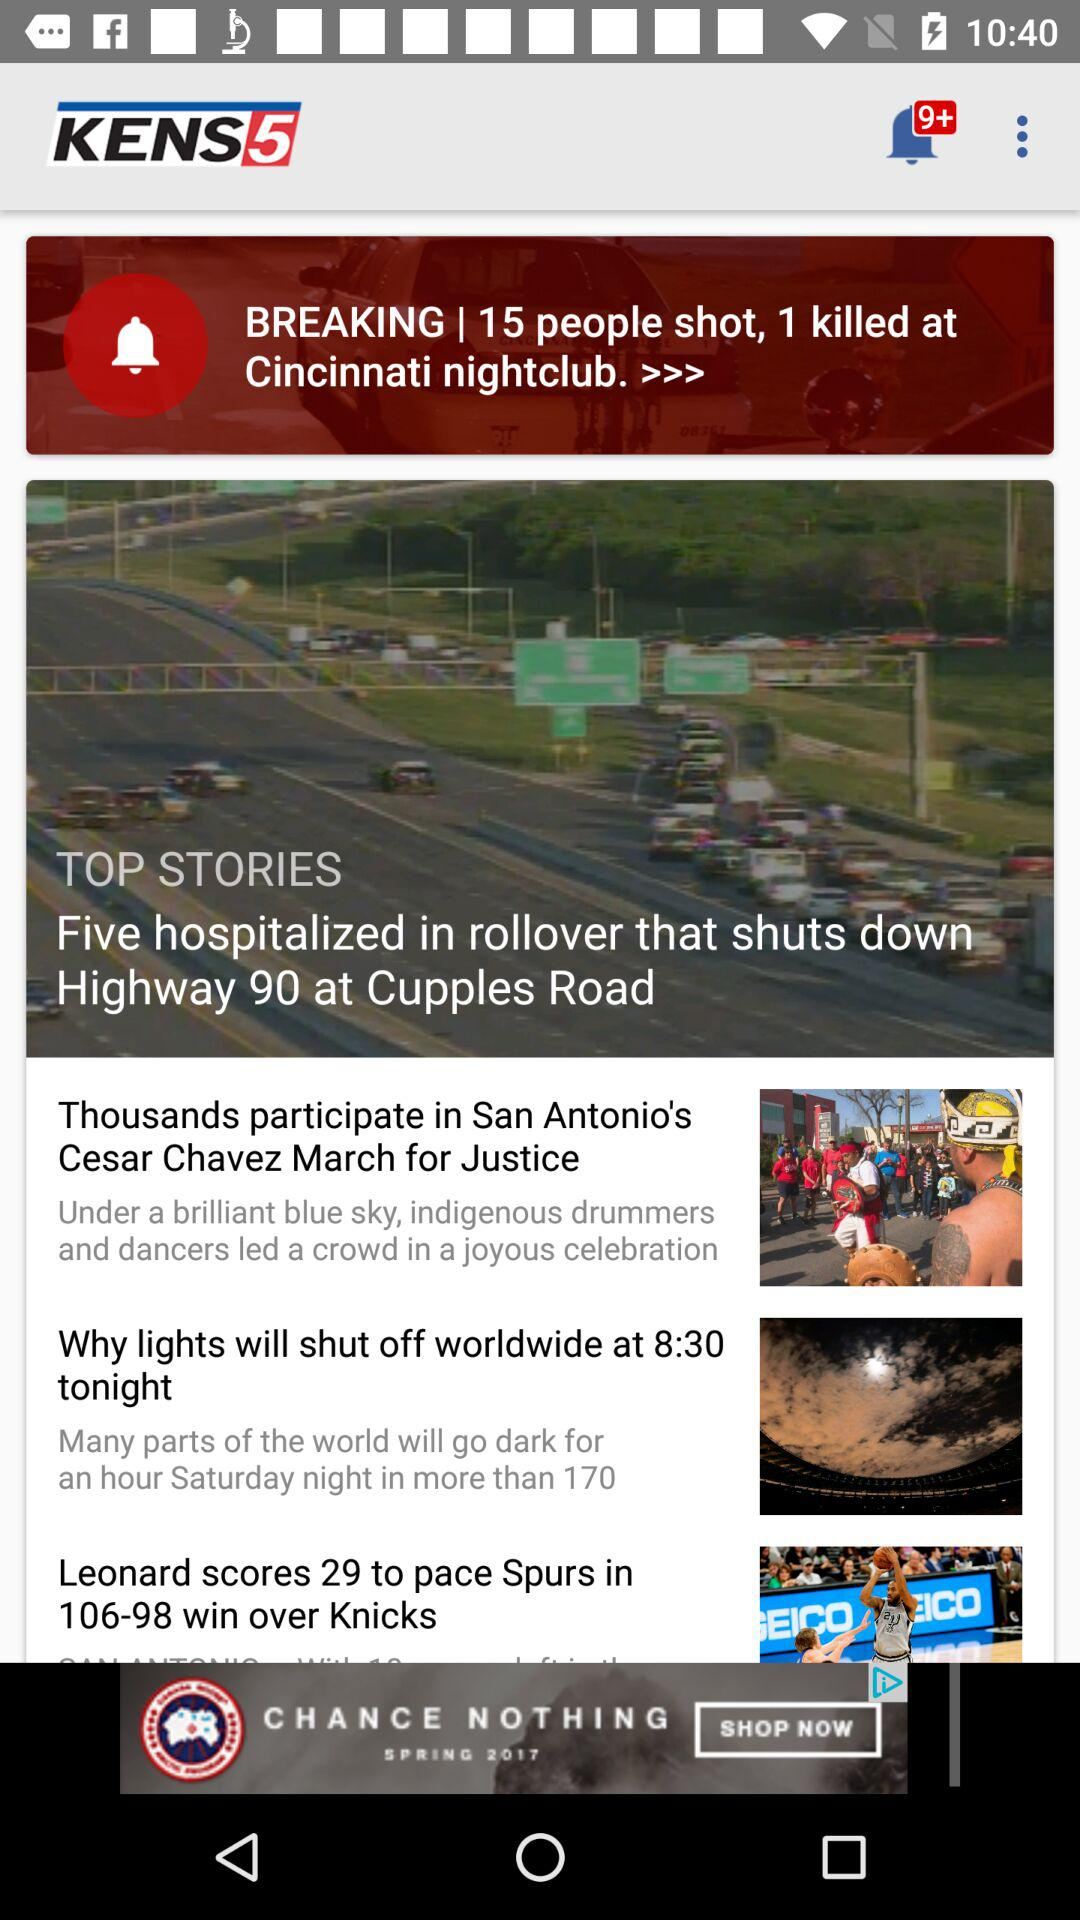What are the top stories? The top stories are "Five hospitalized in rollover that shuts down Highway 90 at Cupples Road", "Thousands participate in San Antonio's Cesar Chavez March for Justice", "Why lights will shut off worldwide at 8:30 tonight" and "Leonard scores 29 to pace Spurs in 106-98 win over Knicks". 